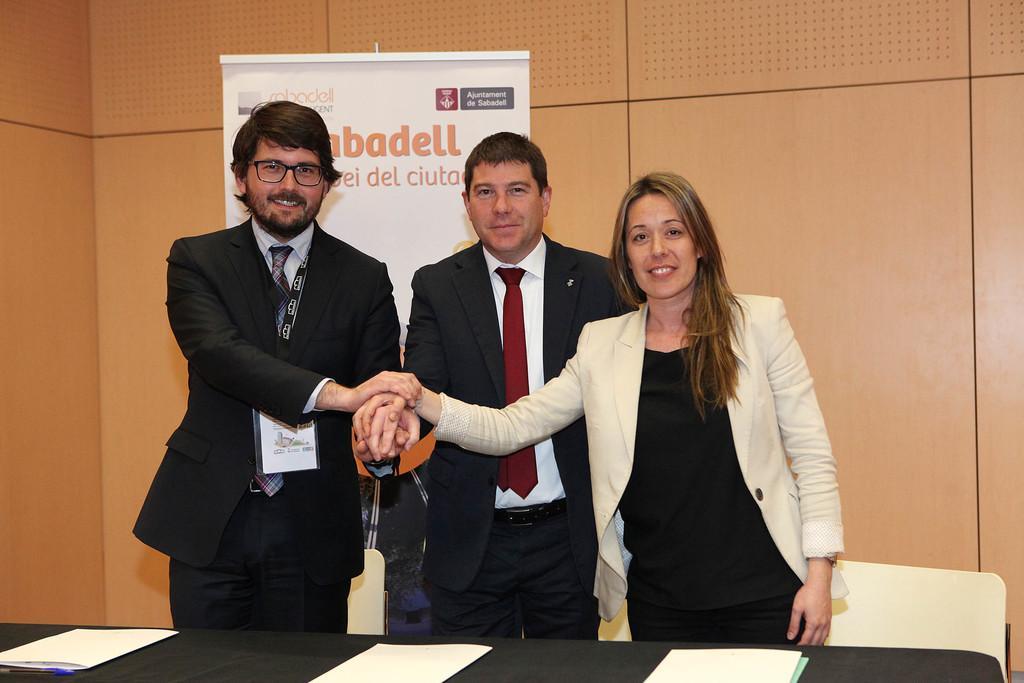Describe this image in one or two sentences. In this picture there is a man who is wearing spectacle and suit, beside him there is another man is wearing blazer, shirt, tie and trouser. Beside him there is a woman who is wearing white blazer and black dress. Three of them are holding their hands. They are standing near to the chairs and table. On the table I can see the papers, pad and other objects. Behind them there is a banner which is placed on the wall. 